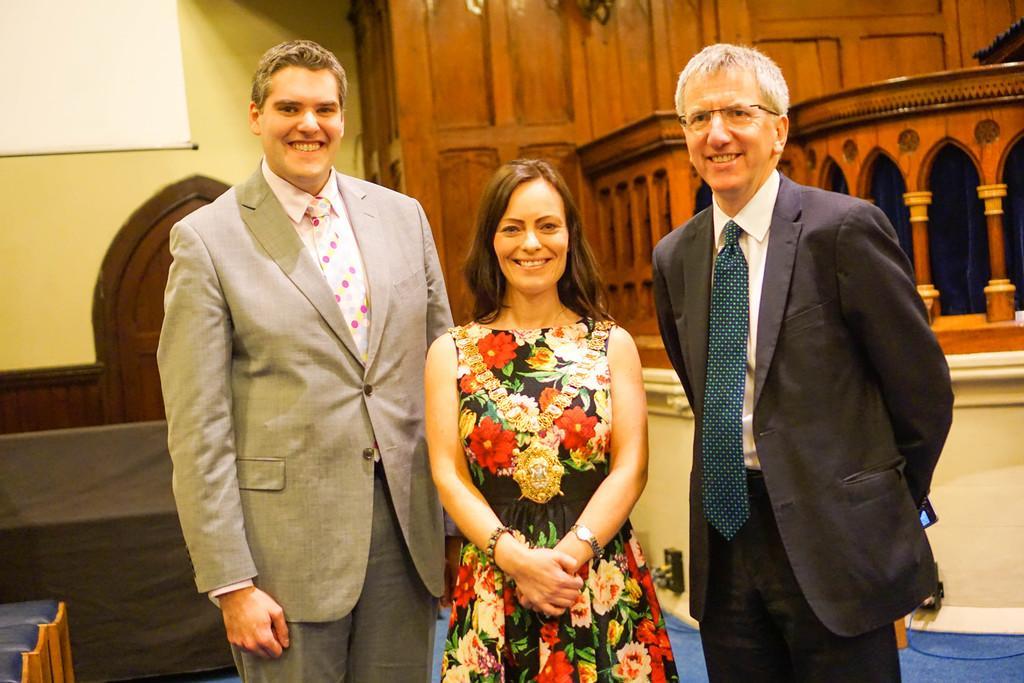In one or two sentences, can you explain what this image depicts? In this picture we can see three persons standing. Behind the three persons, there are cables, a wooden architecture and some objects. In the top left corner of the image, it looks like a projector screen and there is a wall. In the bottom left corner of the image, those are looking like chairs. 